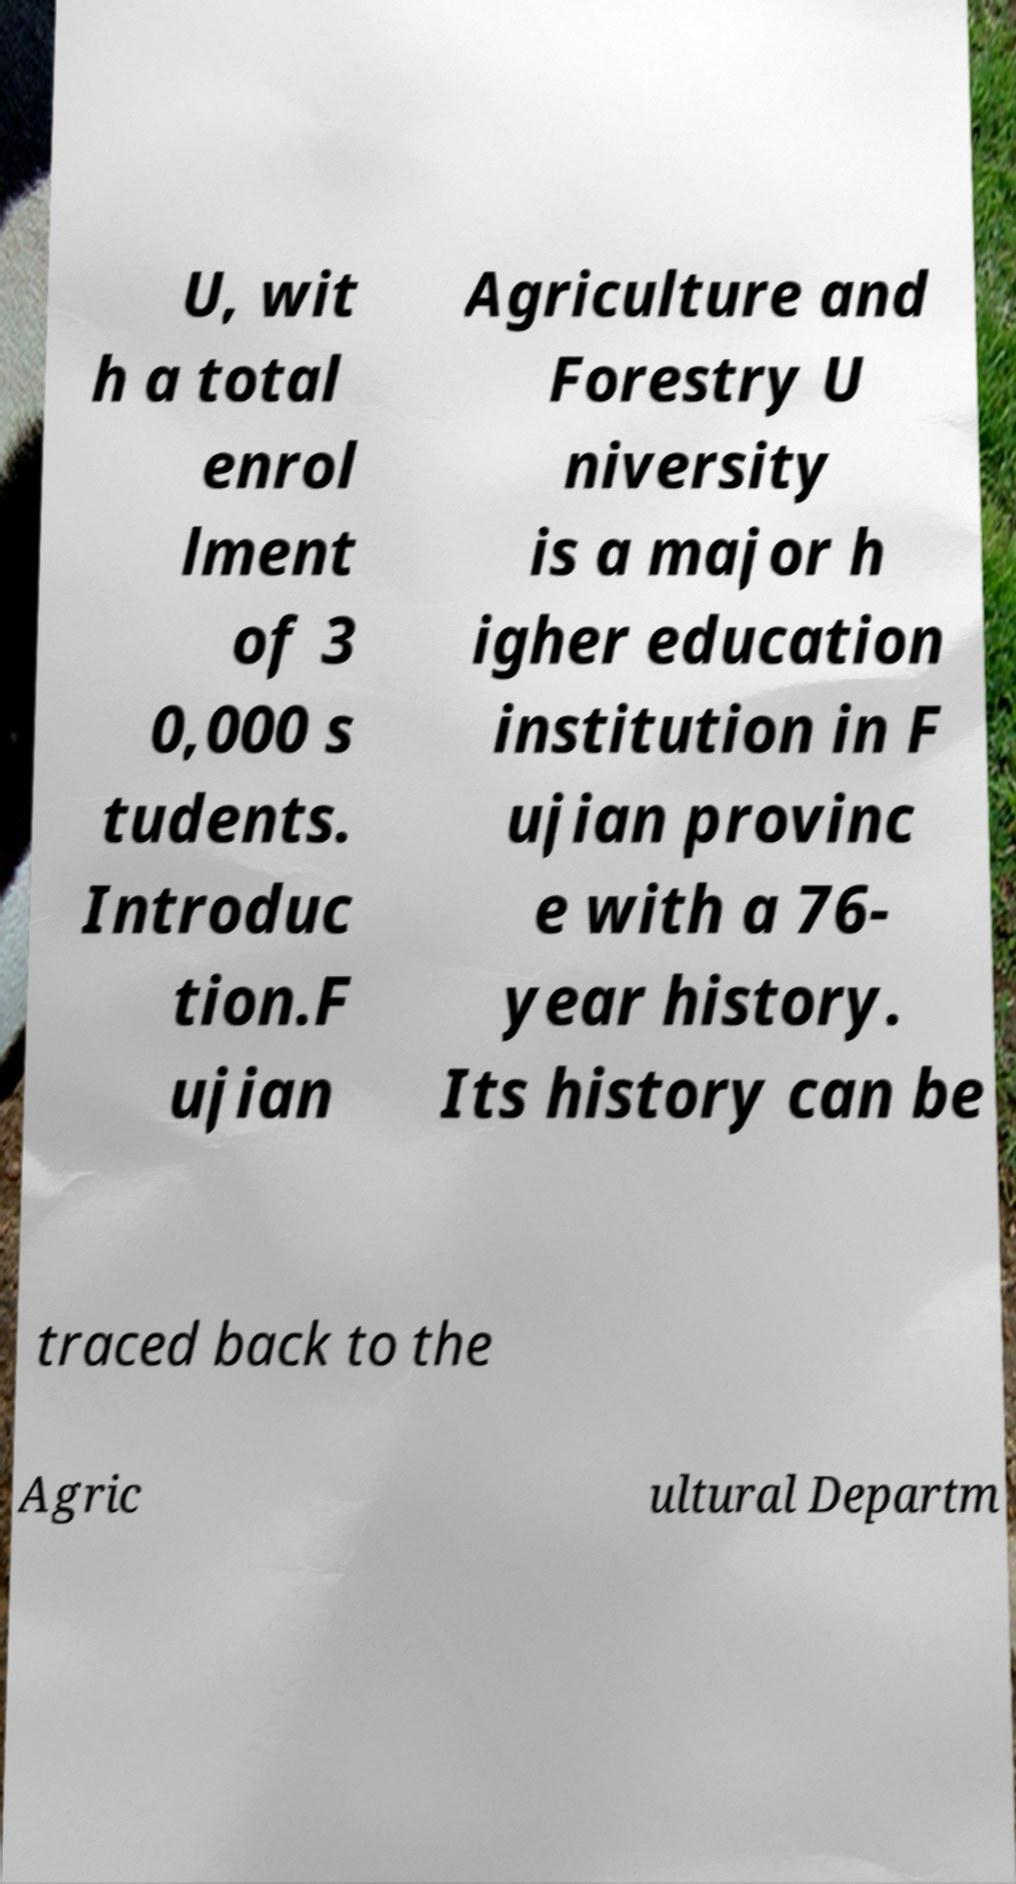There's text embedded in this image that I need extracted. Can you transcribe it verbatim? U, wit h a total enrol lment of 3 0,000 s tudents. Introduc tion.F ujian Agriculture and Forestry U niversity is a major h igher education institution in F ujian provinc e with a 76- year history. Its history can be traced back to the Agric ultural Departm 